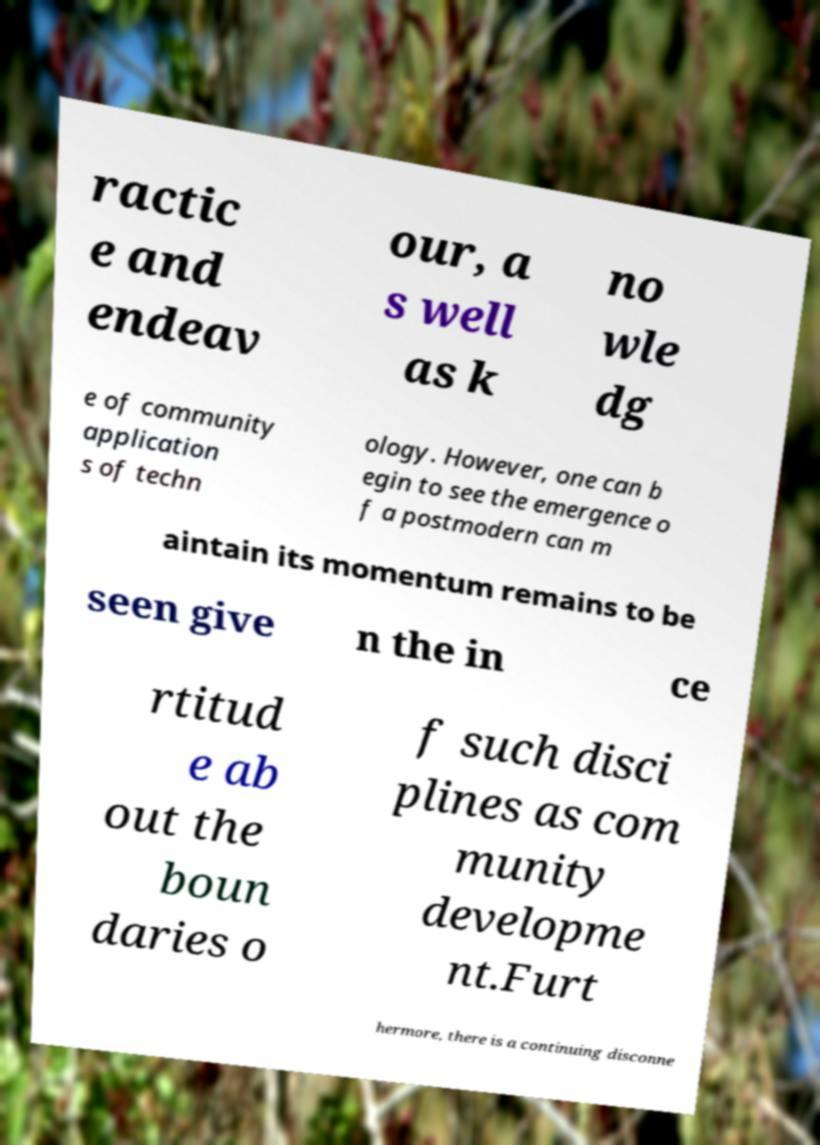For documentation purposes, I need the text within this image transcribed. Could you provide that? ractic e and endeav our, a s well as k no wle dg e of community application s of techn ology. However, one can b egin to see the emergence o f a postmodern can m aintain its momentum remains to be seen give n the in ce rtitud e ab out the boun daries o f such disci plines as com munity developme nt.Furt hermore, there is a continuing disconne 